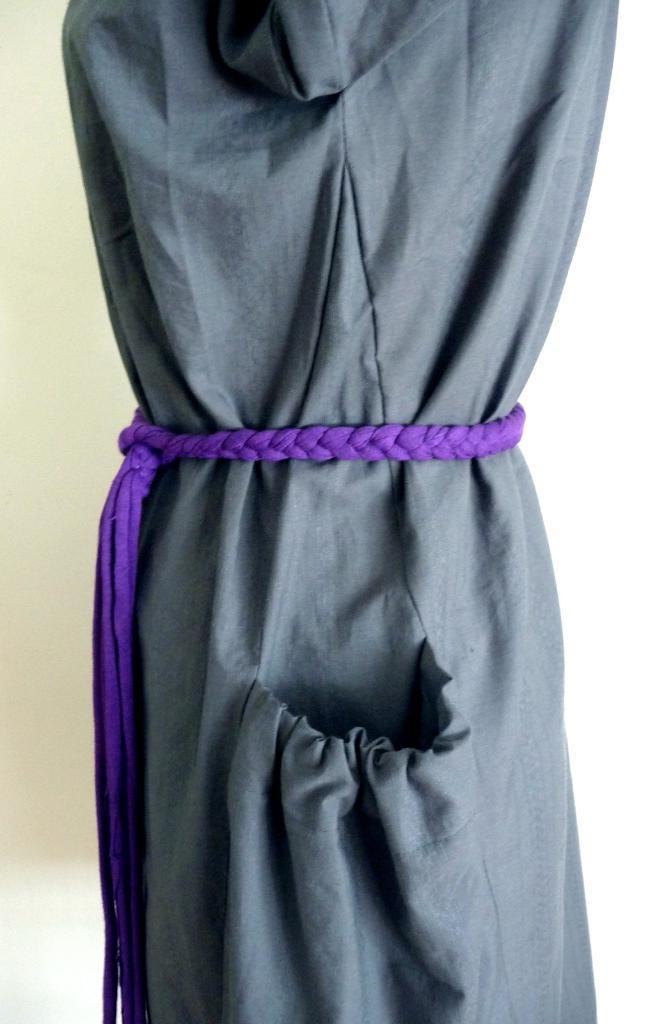Describe this image in one or two sentences. In this picture I can see there is a dress, it has a belt and a pocket. In the backdrop I can see there is a white surface. 